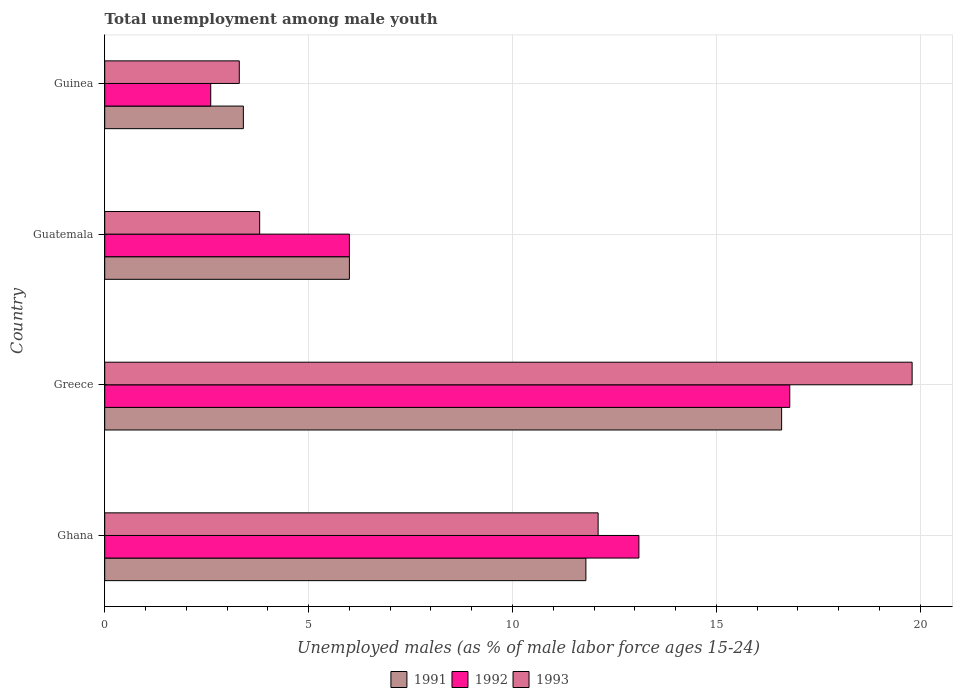How many different coloured bars are there?
Keep it short and to the point. 3. How many groups of bars are there?
Offer a terse response. 4. Are the number of bars per tick equal to the number of legend labels?
Provide a short and direct response. Yes. Are the number of bars on each tick of the Y-axis equal?
Give a very brief answer. Yes. What is the label of the 1st group of bars from the top?
Provide a succinct answer. Guinea. What is the percentage of unemployed males in in 1993 in Greece?
Keep it short and to the point. 19.8. Across all countries, what is the maximum percentage of unemployed males in in 1991?
Offer a very short reply. 16.6. Across all countries, what is the minimum percentage of unemployed males in in 1991?
Make the answer very short. 3.4. In which country was the percentage of unemployed males in in 1993 maximum?
Give a very brief answer. Greece. In which country was the percentage of unemployed males in in 1993 minimum?
Provide a short and direct response. Guinea. What is the total percentage of unemployed males in in 1992 in the graph?
Provide a short and direct response. 38.5. What is the difference between the percentage of unemployed males in in 1993 in Ghana and that in Guatemala?
Give a very brief answer. 8.3. What is the difference between the percentage of unemployed males in in 1992 in Ghana and the percentage of unemployed males in in 1991 in Guinea?
Offer a very short reply. 9.7. What is the average percentage of unemployed males in in 1992 per country?
Offer a very short reply. 9.62. What is the difference between the percentage of unemployed males in in 1992 and percentage of unemployed males in in 1993 in Guinea?
Your answer should be very brief. -0.7. In how many countries, is the percentage of unemployed males in in 1993 greater than 15 %?
Offer a very short reply. 1. What is the ratio of the percentage of unemployed males in in 1992 in Ghana to that in Greece?
Ensure brevity in your answer.  0.78. Is the percentage of unemployed males in in 1993 in Greece less than that in Guinea?
Offer a terse response. No. What is the difference between the highest and the second highest percentage of unemployed males in in 1993?
Give a very brief answer. 7.7. What is the difference between the highest and the lowest percentage of unemployed males in in 1993?
Ensure brevity in your answer.  16.5. In how many countries, is the percentage of unemployed males in in 1993 greater than the average percentage of unemployed males in in 1993 taken over all countries?
Offer a terse response. 2. Is the sum of the percentage of unemployed males in in 1992 in Ghana and Guinea greater than the maximum percentage of unemployed males in in 1991 across all countries?
Provide a short and direct response. No. Is it the case that in every country, the sum of the percentage of unemployed males in in 1993 and percentage of unemployed males in in 1991 is greater than the percentage of unemployed males in in 1992?
Keep it short and to the point. Yes. How many bars are there?
Your response must be concise. 12. Are all the bars in the graph horizontal?
Give a very brief answer. Yes. How many countries are there in the graph?
Offer a terse response. 4. Does the graph contain any zero values?
Offer a very short reply. No. Does the graph contain grids?
Offer a terse response. Yes. How many legend labels are there?
Provide a short and direct response. 3. What is the title of the graph?
Provide a short and direct response. Total unemployment among male youth. Does "1961" appear as one of the legend labels in the graph?
Offer a very short reply. No. What is the label or title of the X-axis?
Your answer should be compact. Unemployed males (as % of male labor force ages 15-24). What is the Unemployed males (as % of male labor force ages 15-24) of 1991 in Ghana?
Make the answer very short. 11.8. What is the Unemployed males (as % of male labor force ages 15-24) in 1992 in Ghana?
Your answer should be compact. 13.1. What is the Unemployed males (as % of male labor force ages 15-24) in 1993 in Ghana?
Provide a short and direct response. 12.1. What is the Unemployed males (as % of male labor force ages 15-24) of 1991 in Greece?
Offer a terse response. 16.6. What is the Unemployed males (as % of male labor force ages 15-24) in 1992 in Greece?
Make the answer very short. 16.8. What is the Unemployed males (as % of male labor force ages 15-24) of 1993 in Greece?
Your response must be concise. 19.8. What is the Unemployed males (as % of male labor force ages 15-24) in 1993 in Guatemala?
Keep it short and to the point. 3.8. What is the Unemployed males (as % of male labor force ages 15-24) of 1991 in Guinea?
Offer a terse response. 3.4. What is the Unemployed males (as % of male labor force ages 15-24) in 1992 in Guinea?
Make the answer very short. 2.6. What is the Unemployed males (as % of male labor force ages 15-24) in 1993 in Guinea?
Make the answer very short. 3.3. Across all countries, what is the maximum Unemployed males (as % of male labor force ages 15-24) in 1991?
Ensure brevity in your answer.  16.6. Across all countries, what is the maximum Unemployed males (as % of male labor force ages 15-24) of 1992?
Ensure brevity in your answer.  16.8. Across all countries, what is the maximum Unemployed males (as % of male labor force ages 15-24) of 1993?
Keep it short and to the point. 19.8. Across all countries, what is the minimum Unemployed males (as % of male labor force ages 15-24) in 1991?
Give a very brief answer. 3.4. Across all countries, what is the minimum Unemployed males (as % of male labor force ages 15-24) in 1992?
Make the answer very short. 2.6. Across all countries, what is the minimum Unemployed males (as % of male labor force ages 15-24) of 1993?
Ensure brevity in your answer.  3.3. What is the total Unemployed males (as % of male labor force ages 15-24) in 1991 in the graph?
Provide a succinct answer. 37.8. What is the total Unemployed males (as % of male labor force ages 15-24) of 1992 in the graph?
Your response must be concise. 38.5. What is the difference between the Unemployed males (as % of male labor force ages 15-24) in 1993 in Ghana and that in Greece?
Offer a very short reply. -7.7. What is the difference between the Unemployed males (as % of male labor force ages 15-24) of 1992 in Ghana and that in Guatemala?
Offer a terse response. 7.1. What is the difference between the Unemployed males (as % of male labor force ages 15-24) in 1992 in Ghana and that in Guinea?
Your answer should be very brief. 10.5. What is the difference between the Unemployed males (as % of male labor force ages 15-24) of 1993 in Ghana and that in Guinea?
Provide a succinct answer. 8.8. What is the difference between the Unemployed males (as % of male labor force ages 15-24) in 1992 in Greece and that in Guatemala?
Your answer should be compact. 10.8. What is the difference between the Unemployed males (as % of male labor force ages 15-24) in 1991 in Guatemala and that in Guinea?
Your answer should be very brief. 2.6. What is the difference between the Unemployed males (as % of male labor force ages 15-24) in 1991 in Ghana and the Unemployed males (as % of male labor force ages 15-24) in 1992 in Greece?
Your answer should be compact. -5. What is the difference between the Unemployed males (as % of male labor force ages 15-24) in 1992 in Ghana and the Unemployed males (as % of male labor force ages 15-24) in 1993 in Guatemala?
Make the answer very short. 9.3. What is the difference between the Unemployed males (as % of male labor force ages 15-24) of 1991 in Ghana and the Unemployed males (as % of male labor force ages 15-24) of 1992 in Guinea?
Provide a short and direct response. 9.2. What is the difference between the Unemployed males (as % of male labor force ages 15-24) in 1991 in Ghana and the Unemployed males (as % of male labor force ages 15-24) in 1993 in Guinea?
Offer a very short reply. 8.5. What is the difference between the Unemployed males (as % of male labor force ages 15-24) in 1991 in Greece and the Unemployed males (as % of male labor force ages 15-24) in 1992 in Guatemala?
Provide a short and direct response. 10.6. What is the difference between the Unemployed males (as % of male labor force ages 15-24) of 1992 in Greece and the Unemployed males (as % of male labor force ages 15-24) of 1993 in Guatemala?
Provide a succinct answer. 13. What is the difference between the Unemployed males (as % of male labor force ages 15-24) of 1991 in Greece and the Unemployed males (as % of male labor force ages 15-24) of 1993 in Guinea?
Your response must be concise. 13.3. What is the difference between the Unemployed males (as % of male labor force ages 15-24) in 1991 in Guatemala and the Unemployed males (as % of male labor force ages 15-24) in 1992 in Guinea?
Keep it short and to the point. 3.4. What is the average Unemployed males (as % of male labor force ages 15-24) in 1991 per country?
Make the answer very short. 9.45. What is the average Unemployed males (as % of male labor force ages 15-24) in 1992 per country?
Keep it short and to the point. 9.62. What is the average Unemployed males (as % of male labor force ages 15-24) in 1993 per country?
Ensure brevity in your answer.  9.75. What is the difference between the Unemployed males (as % of male labor force ages 15-24) of 1991 and Unemployed males (as % of male labor force ages 15-24) of 1993 in Ghana?
Provide a short and direct response. -0.3. What is the difference between the Unemployed males (as % of male labor force ages 15-24) in 1991 and Unemployed males (as % of male labor force ages 15-24) in 1992 in Greece?
Your answer should be very brief. -0.2. What is the difference between the Unemployed males (as % of male labor force ages 15-24) of 1991 and Unemployed males (as % of male labor force ages 15-24) of 1992 in Guatemala?
Ensure brevity in your answer.  0. What is the difference between the Unemployed males (as % of male labor force ages 15-24) of 1991 and Unemployed males (as % of male labor force ages 15-24) of 1993 in Guatemala?
Offer a very short reply. 2.2. What is the difference between the Unemployed males (as % of male labor force ages 15-24) in 1991 and Unemployed males (as % of male labor force ages 15-24) in 1993 in Guinea?
Provide a short and direct response. 0.1. What is the ratio of the Unemployed males (as % of male labor force ages 15-24) in 1991 in Ghana to that in Greece?
Offer a very short reply. 0.71. What is the ratio of the Unemployed males (as % of male labor force ages 15-24) in 1992 in Ghana to that in Greece?
Provide a succinct answer. 0.78. What is the ratio of the Unemployed males (as % of male labor force ages 15-24) in 1993 in Ghana to that in Greece?
Your response must be concise. 0.61. What is the ratio of the Unemployed males (as % of male labor force ages 15-24) of 1991 in Ghana to that in Guatemala?
Your answer should be compact. 1.97. What is the ratio of the Unemployed males (as % of male labor force ages 15-24) of 1992 in Ghana to that in Guatemala?
Your answer should be very brief. 2.18. What is the ratio of the Unemployed males (as % of male labor force ages 15-24) of 1993 in Ghana to that in Guatemala?
Provide a succinct answer. 3.18. What is the ratio of the Unemployed males (as % of male labor force ages 15-24) of 1991 in Ghana to that in Guinea?
Provide a succinct answer. 3.47. What is the ratio of the Unemployed males (as % of male labor force ages 15-24) in 1992 in Ghana to that in Guinea?
Provide a short and direct response. 5.04. What is the ratio of the Unemployed males (as % of male labor force ages 15-24) in 1993 in Ghana to that in Guinea?
Keep it short and to the point. 3.67. What is the ratio of the Unemployed males (as % of male labor force ages 15-24) in 1991 in Greece to that in Guatemala?
Your response must be concise. 2.77. What is the ratio of the Unemployed males (as % of male labor force ages 15-24) of 1992 in Greece to that in Guatemala?
Offer a very short reply. 2.8. What is the ratio of the Unemployed males (as % of male labor force ages 15-24) in 1993 in Greece to that in Guatemala?
Keep it short and to the point. 5.21. What is the ratio of the Unemployed males (as % of male labor force ages 15-24) of 1991 in Greece to that in Guinea?
Ensure brevity in your answer.  4.88. What is the ratio of the Unemployed males (as % of male labor force ages 15-24) of 1992 in Greece to that in Guinea?
Your answer should be compact. 6.46. What is the ratio of the Unemployed males (as % of male labor force ages 15-24) of 1991 in Guatemala to that in Guinea?
Your answer should be very brief. 1.76. What is the ratio of the Unemployed males (as % of male labor force ages 15-24) of 1992 in Guatemala to that in Guinea?
Your answer should be very brief. 2.31. What is the ratio of the Unemployed males (as % of male labor force ages 15-24) of 1993 in Guatemala to that in Guinea?
Provide a succinct answer. 1.15. What is the difference between the highest and the second highest Unemployed males (as % of male labor force ages 15-24) of 1992?
Provide a succinct answer. 3.7. What is the difference between the highest and the second highest Unemployed males (as % of male labor force ages 15-24) in 1993?
Offer a terse response. 7.7. What is the difference between the highest and the lowest Unemployed males (as % of male labor force ages 15-24) of 1993?
Ensure brevity in your answer.  16.5. 